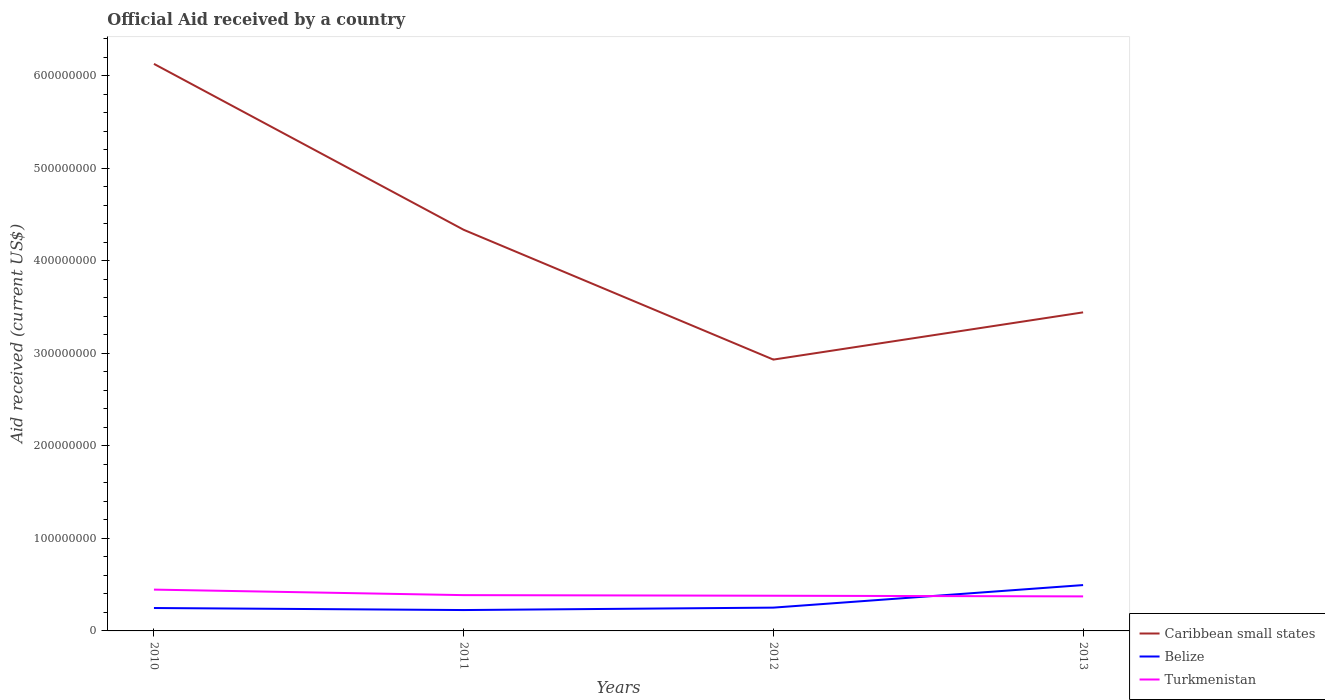Does the line corresponding to Caribbean small states intersect with the line corresponding to Belize?
Offer a very short reply. No. Across all years, what is the maximum net official aid received in Belize?
Provide a succinct answer. 2.26e+07. In which year was the net official aid received in Caribbean small states maximum?
Provide a succinct answer. 2012. What is the total net official aid received in Turkmenistan in the graph?
Give a very brief answer. 7.33e+06. What is the difference between the highest and the second highest net official aid received in Caribbean small states?
Offer a very short reply. 3.20e+08. Is the net official aid received in Turkmenistan strictly greater than the net official aid received in Belize over the years?
Provide a succinct answer. No. How many lines are there?
Keep it short and to the point. 3. Where does the legend appear in the graph?
Provide a short and direct response. Bottom right. How many legend labels are there?
Offer a very short reply. 3. What is the title of the graph?
Provide a succinct answer. Official Aid received by a country. Does "Bulgaria" appear as one of the legend labels in the graph?
Provide a short and direct response. No. What is the label or title of the Y-axis?
Ensure brevity in your answer.  Aid received (current US$). What is the Aid received (current US$) in Caribbean small states in 2010?
Offer a very short reply. 6.13e+08. What is the Aid received (current US$) of Belize in 2010?
Make the answer very short. 2.48e+07. What is the Aid received (current US$) of Turkmenistan in 2010?
Offer a very short reply. 4.46e+07. What is the Aid received (current US$) in Caribbean small states in 2011?
Ensure brevity in your answer.  4.34e+08. What is the Aid received (current US$) in Belize in 2011?
Ensure brevity in your answer.  2.26e+07. What is the Aid received (current US$) in Turkmenistan in 2011?
Your answer should be very brief. 3.87e+07. What is the Aid received (current US$) in Caribbean small states in 2012?
Keep it short and to the point. 2.93e+08. What is the Aid received (current US$) of Belize in 2012?
Give a very brief answer. 2.52e+07. What is the Aid received (current US$) of Turkmenistan in 2012?
Give a very brief answer. 3.80e+07. What is the Aid received (current US$) in Caribbean small states in 2013?
Provide a succinct answer. 3.44e+08. What is the Aid received (current US$) of Belize in 2013?
Keep it short and to the point. 4.96e+07. What is the Aid received (current US$) of Turkmenistan in 2013?
Your response must be concise. 3.73e+07. Across all years, what is the maximum Aid received (current US$) of Caribbean small states?
Offer a terse response. 6.13e+08. Across all years, what is the maximum Aid received (current US$) in Belize?
Provide a succinct answer. 4.96e+07. Across all years, what is the maximum Aid received (current US$) in Turkmenistan?
Offer a very short reply. 4.46e+07. Across all years, what is the minimum Aid received (current US$) of Caribbean small states?
Provide a short and direct response. 2.93e+08. Across all years, what is the minimum Aid received (current US$) of Belize?
Provide a short and direct response. 2.26e+07. Across all years, what is the minimum Aid received (current US$) in Turkmenistan?
Give a very brief answer. 3.73e+07. What is the total Aid received (current US$) of Caribbean small states in the graph?
Offer a very short reply. 1.68e+09. What is the total Aid received (current US$) of Belize in the graph?
Keep it short and to the point. 1.22e+08. What is the total Aid received (current US$) of Turkmenistan in the graph?
Offer a very short reply. 1.59e+08. What is the difference between the Aid received (current US$) in Caribbean small states in 2010 and that in 2011?
Offer a very short reply. 1.79e+08. What is the difference between the Aid received (current US$) in Belize in 2010 and that in 2011?
Your answer should be very brief. 2.20e+06. What is the difference between the Aid received (current US$) of Turkmenistan in 2010 and that in 2011?
Offer a terse response. 5.97e+06. What is the difference between the Aid received (current US$) in Caribbean small states in 2010 and that in 2012?
Your answer should be compact. 3.20e+08. What is the difference between the Aid received (current US$) in Belize in 2010 and that in 2012?
Ensure brevity in your answer.  -4.20e+05. What is the difference between the Aid received (current US$) of Turkmenistan in 2010 and that in 2012?
Offer a terse response. 6.62e+06. What is the difference between the Aid received (current US$) in Caribbean small states in 2010 and that in 2013?
Offer a terse response. 2.69e+08. What is the difference between the Aid received (current US$) in Belize in 2010 and that in 2013?
Your response must be concise. -2.48e+07. What is the difference between the Aid received (current US$) in Turkmenistan in 2010 and that in 2013?
Your answer should be compact. 7.33e+06. What is the difference between the Aid received (current US$) of Caribbean small states in 2011 and that in 2012?
Offer a terse response. 1.40e+08. What is the difference between the Aid received (current US$) in Belize in 2011 and that in 2012?
Provide a succinct answer. -2.62e+06. What is the difference between the Aid received (current US$) of Turkmenistan in 2011 and that in 2012?
Ensure brevity in your answer.  6.50e+05. What is the difference between the Aid received (current US$) of Caribbean small states in 2011 and that in 2013?
Your answer should be very brief. 8.92e+07. What is the difference between the Aid received (current US$) of Belize in 2011 and that in 2013?
Keep it short and to the point. -2.70e+07. What is the difference between the Aid received (current US$) in Turkmenistan in 2011 and that in 2013?
Make the answer very short. 1.36e+06. What is the difference between the Aid received (current US$) of Caribbean small states in 2012 and that in 2013?
Ensure brevity in your answer.  -5.10e+07. What is the difference between the Aid received (current US$) in Belize in 2012 and that in 2013?
Keep it short and to the point. -2.44e+07. What is the difference between the Aid received (current US$) of Turkmenistan in 2012 and that in 2013?
Make the answer very short. 7.10e+05. What is the difference between the Aid received (current US$) in Caribbean small states in 2010 and the Aid received (current US$) in Belize in 2011?
Provide a short and direct response. 5.90e+08. What is the difference between the Aid received (current US$) in Caribbean small states in 2010 and the Aid received (current US$) in Turkmenistan in 2011?
Make the answer very short. 5.74e+08. What is the difference between the Aid received (current US$) of Belize in 2010 and the Aid received (current US$) of Turkmenistan in 2011?
Your answer should be compact. -1.39e+07. What is the difference between the Aid received (current US$) of Caribbean small states in 2010 and the Aid received (current US$) of Belize in 2012?
Ensure brevity in your answer.  5.88e+08. What is the difference between the Aid received (current US$) of Caribbean small states in 2010 and the Aid received (current US$) of Turkmenistan in 2012?
Your answer should be very brief. 5.75e+08. What is the difference between the Aid received (current US$) of Belize in 2010 and the Aid received (current US$) of Turkmenistan in 2012?
Offer a very short reply. -1.33e+07. What is the difference between the Aid received (current US$) in Caribbean small states in 2010 and the Aid received (current US$) in Belize in 2013?
Your answer should be compact. 5.63e+08. What is the difference between the Aid received (current US$) in Caribbean small states in 2010 and the Aid received (current US$) in Turkmenistan in 2013?
Provide a succinct answer. 5.76e+08. What is the difference between the Aid received (current US$) in Belize in 2010 and the Aid received (current US$) in Turkmenistan in 2013?
Keep it short and to the point. -1.26e+07. What is the difference between the Aid received (current US$) in Caribbean small states in 2011 and the Aid received (current US$) in Belize in 2012?
Provide a short and direct response. 4.08e+08. What is the difference between the Aid received (current US$) in Caribbean small states in 2011 and the Aid received (current US$) in Turkmenistan in 2012?
Provide a short and direct response. 3.96e+08. What is the difference between the Aid received (current US$) of Belize in 2011 and the Aid received (current US$) of Turkmenistan in 2012?
Offer a terse response. -1.55e+07. What is the difference between the Aid received (current US$) in Caribbean small states in 2011 and the Aid received (current US$) in Belize in 2013?
Your answer should be very brief. 3.84e+08. What is the difference between the Aid received (current US$) of Caribbean small states in 2011 and the Aid received (current US$) of Turkmenistan in 2013?
Make the answer very short. 3.96e+08. What is the difference between the Aid received (current US$) in Belize in 2011 and the Aid received (current US$) in Turkmenistan in 2013?
Keep it short and to the point. -1.48e+07. What is the difference between the Aid received (current US$) of Caribbean small states in 2012 and the Aid received (current US$) of Belize in 2013?
Provide a short and direct response. 2.44e+08. What is the difference between the Aid received (current US$) of Caribbean small states in 2012 and the Aid received (current US$) of Turkmenistan in 2013?
Make the answer very short. 2.56e+08. What is the difference between the Aid received (current US$) of Belize in 2012 and the Aid received (current US$) of Turkmenistan in 2013?
Your answer should be compact. -1.21e+07. What is the average Aid received (current US$) of Caribbean small states per year?
Offer a very short reply. 4.21e+08. What is the average Aid received (current US$) of Belize per year?
Offer a very short reply. 3.05e+07. What is the average Aid received (current US$) of Turkmenistan per year?
Your answer should be very brief. 3.97e+07. In the year 2010, what is the difference between the Aid received (current US$) of Caribbean small states and Aid received (current US$) of Belize?
Offer a terse response. 5.88e+08. In the year 2010, what is the difference between the Aid received (current US$) of Caribbean small states and Aid received (current US$) of Turkmenistan?
Your answer should be compact. 5.68e+08. In the year 2010, what is the difference between the Aid received (current US$) in Belize and Aid received (current US$) in Turkmenistan?
Offer a very short reply. -1.99e+07. In the year 2011, what is the difference between the Aid received (current US$) in Caribbean small states and Aid received (current US$) in Belize?
Offer a terse response. 4.11e+08. In the year 2011, what is the difference between the Aid received (current US$) of Caribbean small states and Aid received (current US$) of Turkmenistan?
Give a very brief answer. 3.95e+08. In the year 2011, what is the difference between the Aid received (current US$) of Belize and Aid received (current US$) of Turkmenistan?
Make the answer very short. -1.61e+07. In the year 2012, what is the difference between the Aid received (current US$) of Caribbean small states and Aid received (current US$) of Belize?
Give a very brief answer. 2.68e+08. In the year 2012, what is the difference between the Aid received (current US$) of Caribbean small states and Aid received (current US$) of Turkmenistan?
Offer a terse response. 2.55e+08. In the year 2012, what is the difference between the Aid received (current US$) in Belize and Aid received (current US$) in Turkmenistan?
Offer a very short reply. -1.28e+07. In the year 2013, what is the difference between the Aid received (current US$) in Caribbean small states and Aid received (current US$) in Belize?
Your answer should be very brief. 2.95e+08. In the year 2013, what is the difference between the Aid received (current US$) in Caribbean small states and Aid received (current US$) in Turkmenistan?
Offer a very short reply. 3.07e+08. In the year 2013, what is the difference between the Aid received (current US$) in Belize and Aid received (current US$) in Turkmenistan?
Provide a short and direct response. 1.22e+07. What is the ratio of the Aid received (current US$) of Caribbean small states in 2010 to that in 2011?
Keep it short and to the point. 1.41. What is the ratio of the Aid received (current US$) of Belize in 2010 to that in 2011?
Keep it short and to the point. 1.1. What is the ratio of the Aid received (current US$) in Turkmenistan in 2010 to that in 2011?
Ensure brevity in your answer.  1.15. What is the ratio of the Aid received (current US$) in Caribbean small states in 2010 to that in 2012?
Ensure brevity in your answer.  2.09. What is the ratio of the Aid received (current US$) in Belize in 2010 to that in 2012?
Provide a succinct answer. 0.98. What is the ratio of the Aid received (current US$) of Turkmenistan in 2010 to that in 2012?
Your response must be concise. 1.17. What is the ratio of the Aid received (current US$) in Caribbean small states in 2010 to that in 2013?
Provide a short and direct response. 1.78. What is the ratio of the Aid received (current US$) of Belize in 2010 to that in 2013?
Offer a terse response. 0.5. What is the ratio of the Aid received (current US$) of Turkmenistan in 2010 to that in 2013?
Give a very brief answer. 1.2. What is the ratio of the Aid received (current US$) in Caribbean small states in 2011 to that in 2012?
Offer a very short reply. 1.48. What is the ratio of the Aid received (current US$) of Belize in 2011 to that in 2012?
Your answer should be very brief. 0.9. What is the ratio of the Aid received (current US$) of Turkmenistan in 2011 to that in 2012?
Ensure brevity in your answer.  1.02. What is the ratio of the Aid received (current US$) in Caribbean small states in 2011 to that in 2013?
Provide a short and direct response. 1.26. What is the ratio of the Aid received (current US$) of Belize in 2011 to that in 2013?
Your answer should be compact. 0.46. What is the ratio of the Aid received (current US$) of Turkmenistan in 2011 to that in 2013?
Provide a succinct answer. 1.04. What is the ratio of the Aid received (current US$) of Caribbean small states in 2012 to that in 2013?
Offer a terse response. 0.85. What is the ratio of the Aid received (current US$) in Belize in 2012 to that in 2013?
Provide a succinct answer. 0.51. What is the ratio of the Aid received (current US$) of Turkmenistan in 2012 to that in 2013?
Your answer should be very brief. 1.02. What is the difference between the highest and the second highest Aid received (current US$) of Caribbean small states?
Offer a terse response. 1.79e+08. What is the difference between the highest and the second highest Aid received (current US$) in Belize?
Offer a terse response. 2.44e+07. What is the difference between the highest and the second highest Aid received (current US$) of Turkmenistan?
Give a very brief answer. 5.97e+06. What is the difference between the highest and the lowest Aid received (current US$) of Caribbean small states?
Your response must be concise. 3.20e+08. What is the difference between the highest and the lowest Aid received (current US$) in Belize?
Your response must be concise. 2.70e+07. What is the difference between the highest and the lowest Aid received (current US$) of Turkmenistan?
Your answer should be very brief. 7.33e+06. 